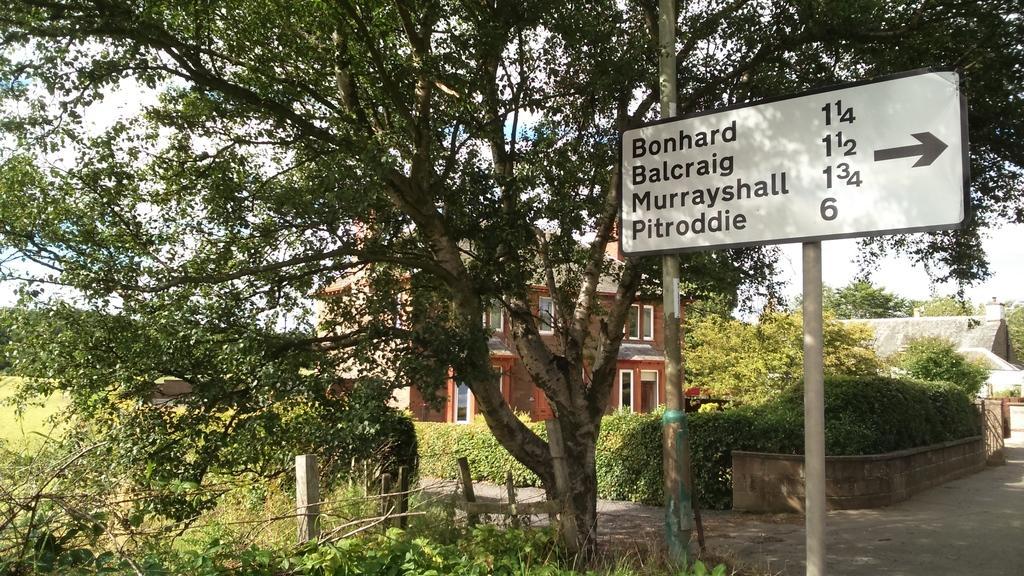In one or two sentences, can you explain what this image depicts? In this image there is a fencing beside the fencing, there are plants trees and there is a pole, on that pole there is a board, on that board there is some text, in the background there is a building and plants and a road. 